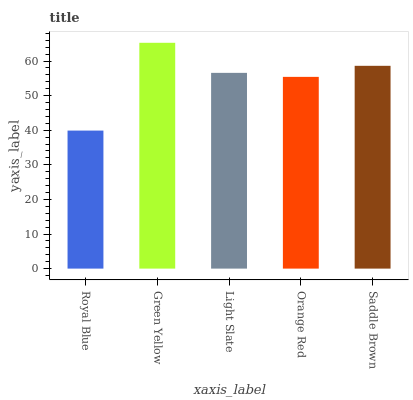Is Royal Blue the minimum?
Answer yes or no. Yes. Is Green Yellow the maximum?
Answer yes or no. Yes. Is Light Slate the minimum?
Answer yes or no. No. Is Light Slate the maximum?
Answer yes or no. No. Is Green Yellow greater than Light Slate?
Answer yes or no. Yes. Is Light Slate less than Green Yellow?
Answer yes or no. Yes. Is Light Slate greater than Green Yellow?
Answer yes or no. No. Is Green Yellow less than Light Slate?
Answer yes or no. No. Is Light Slate the high median?
Answer yes or no. Yes. Is Light Slate the low median?
Answer yes or no. Yes. Is Green Yellow the high median?
Answer yes or no. No. Is Orange Red the low median?
Answer yes or no. No. 